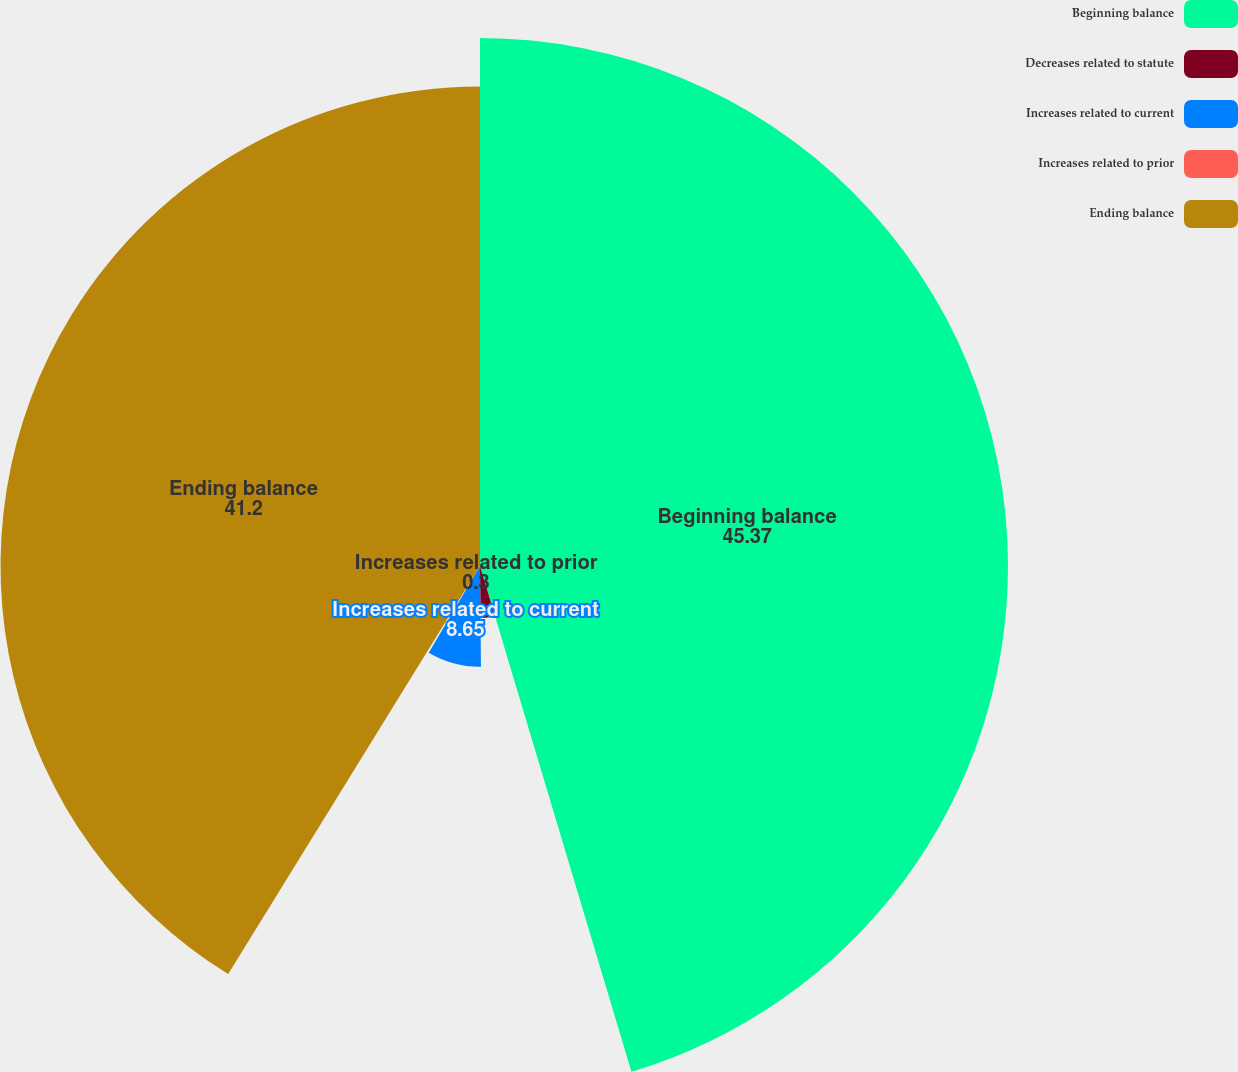Convert chart to OTSL. <chart><loc_0><loc_0><loc_500><loc_500><pie_chart><fcel>Beginning balance<fcel>Decreases related to statute<fcel>Increases related to current<fcel>Increases related to prior<fcel>Ending balance<nl><fcel>45.37%<fcel>4.48%<fcel>8.65%<fcel>0.3%<fcel>41.2%<nl></chart> 